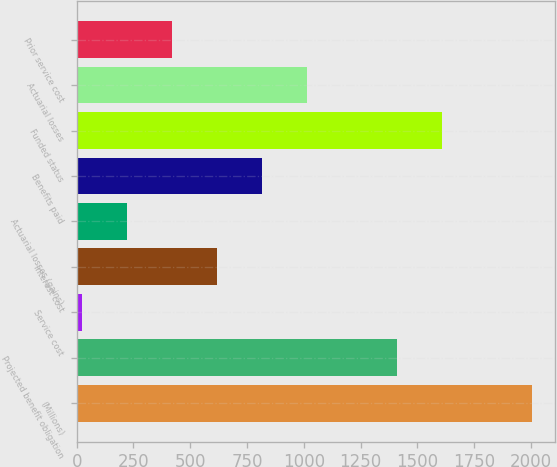Convert chart to OTSL. <chart><loc_0><loc_0><loc_500><loc_500><bar_chart><fcel>(Millions)<fcel>Projected benefit obligation<fcel>Service cost<fcel>Interest cost<fcel>Actuarial losses (gains)<fcel>Benefits paid<fcel>Funded status<fcel>Actuarial losses<fcel>Prior service cost<nl><fcel>2005<fcel>1410.7<fcel>24<fcel>618.3<fcel>222.1<fcel>816.4<fcel>1608.8<fcel>1014.5<fcel>420.2<nl></chart> 